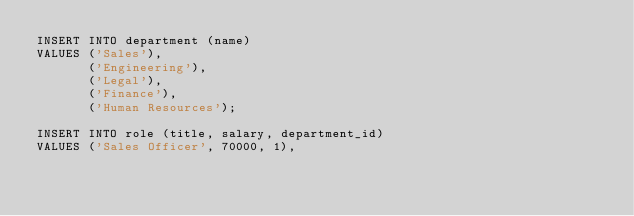Convert code to text. <code><loc_0><loc_0><loc_500><loc_500><_SQL_>INSERT INTO department (name)
VALUES ('Sales'),
       ('Engineering'),
       ('Legal'),
       ('Finance'),
       ('Human Resources');

INSERT INTO role (title, salary, department_id)
VALUES ('Sales Officer', 70000, 1),</code> 